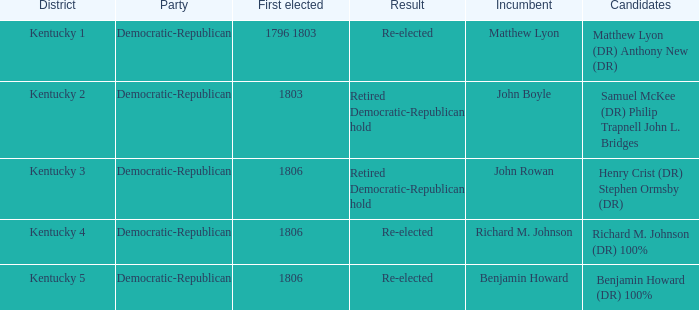Name the incumbent for  matthew lyon (dr) anthony new (dr) Matthew Lyon. 